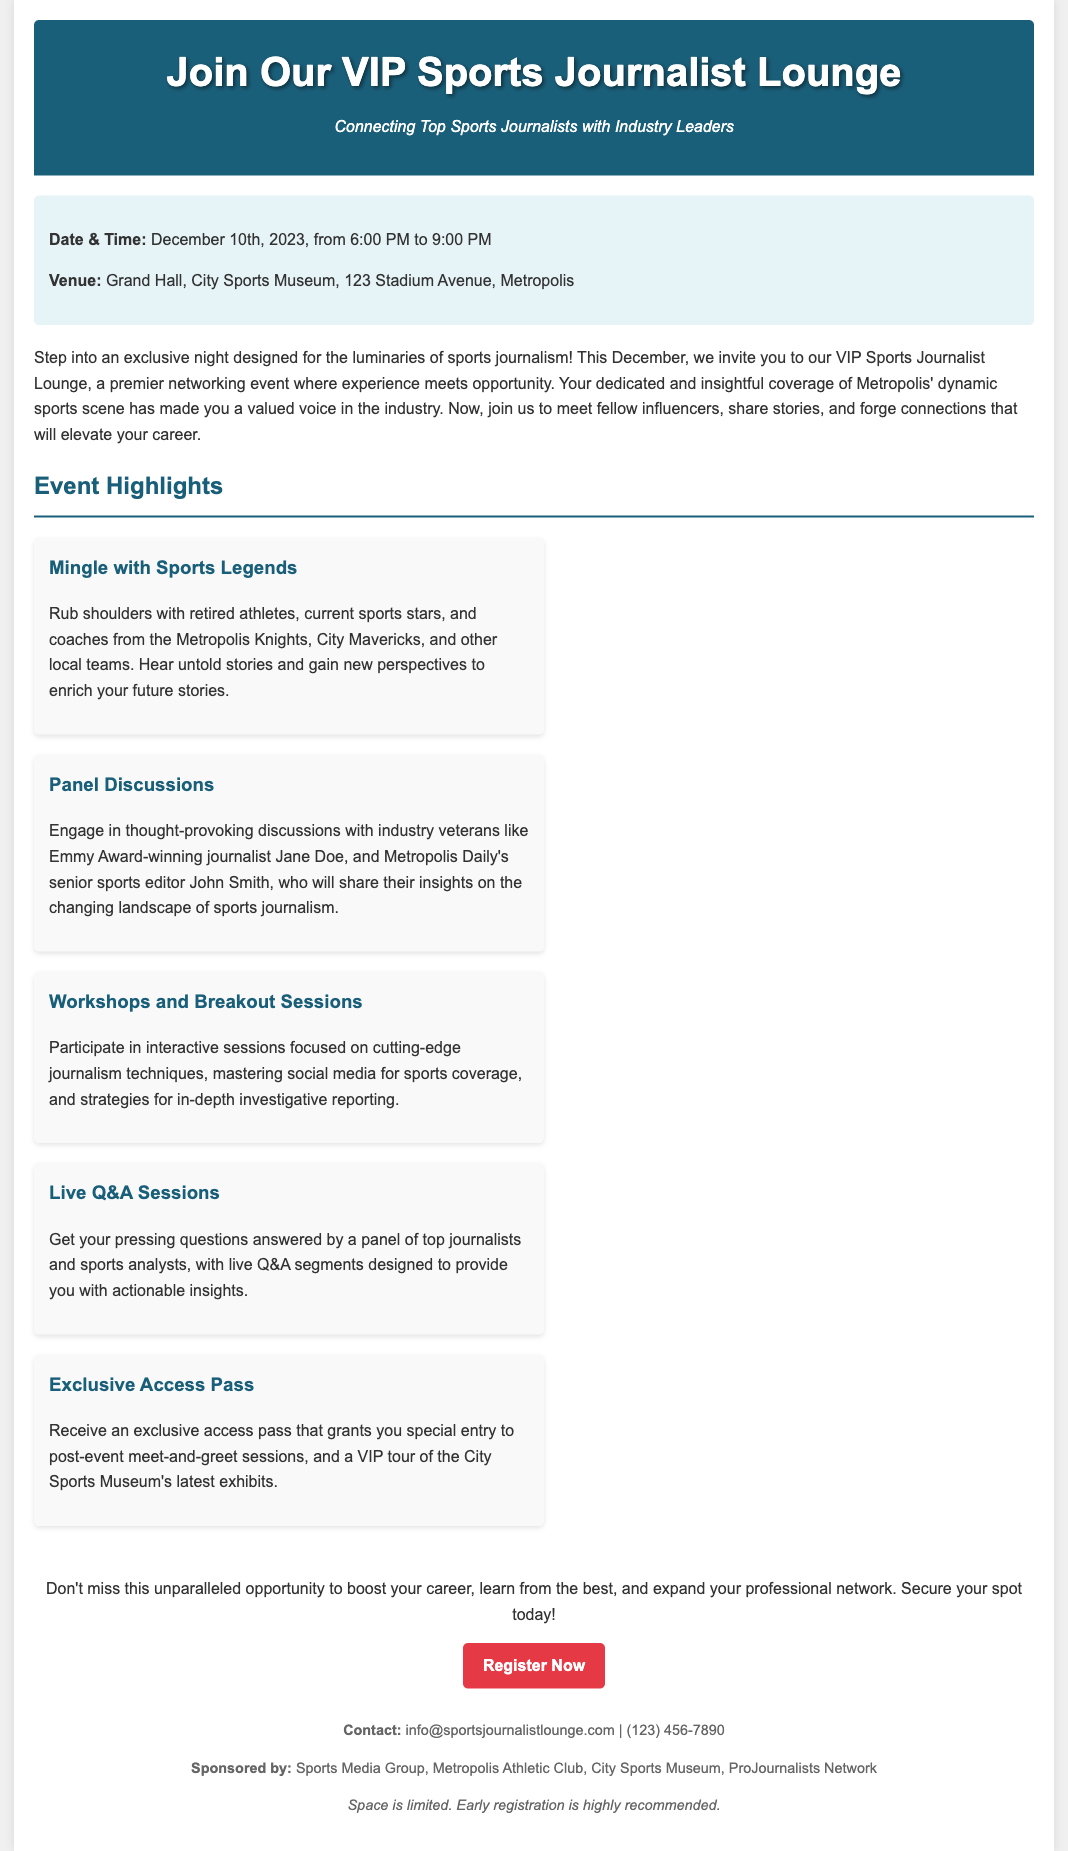What is the date of the event? The document specifies that the event is on December 10th, 2023.
Answer: December 10th, 2023 What is the venue for the event? The event will take place at the Grand Hall, City Sports Museum, located at 123 Stadium Avenue, Metropolis.
Answer: Grand Hall, City Sports Museum Who will be a speaker at the panel discussions? The document mentions Emmy Award-winning journalist Jane Doe as one of the speakers.
Answer: Jane Doe How long will the event last? The event is scheduled from 6:00 PM to 9:00 PM, indicating a duration of three hours.
Answer: 3 hours What can attendees expect from the workshops? The document states that workshops will focus on cutting-edge journalism techniques and social media strategies, among other topics.
Answer: Cutting-edge journalism techniques What type of access is included with the event registration? An exclusive access pass to post-event meet-and-greet sessions is mentioned in the document.
Answer: Exclusive access pass Why is early registration recommended? The document indicates that space is limited, implying that registration may close once capacity is reached.
Answer: Space is limited What organization is sponsoring the event? The document lists Sports Media Group as one of the sponsors.
Answer: Sports Media Group What is the main goal of the VIP Sports Journalist Lounge event? The objective of the event is to connect top sports journalists with industry leaders and to help attendees expand their professional networks.
Answer: Connecting top sports journalists with industry leaders 